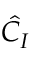<formula> <loc_0><loc_0><loc_500><loc_500>{ \hat { C } } _ { I }</formula> 